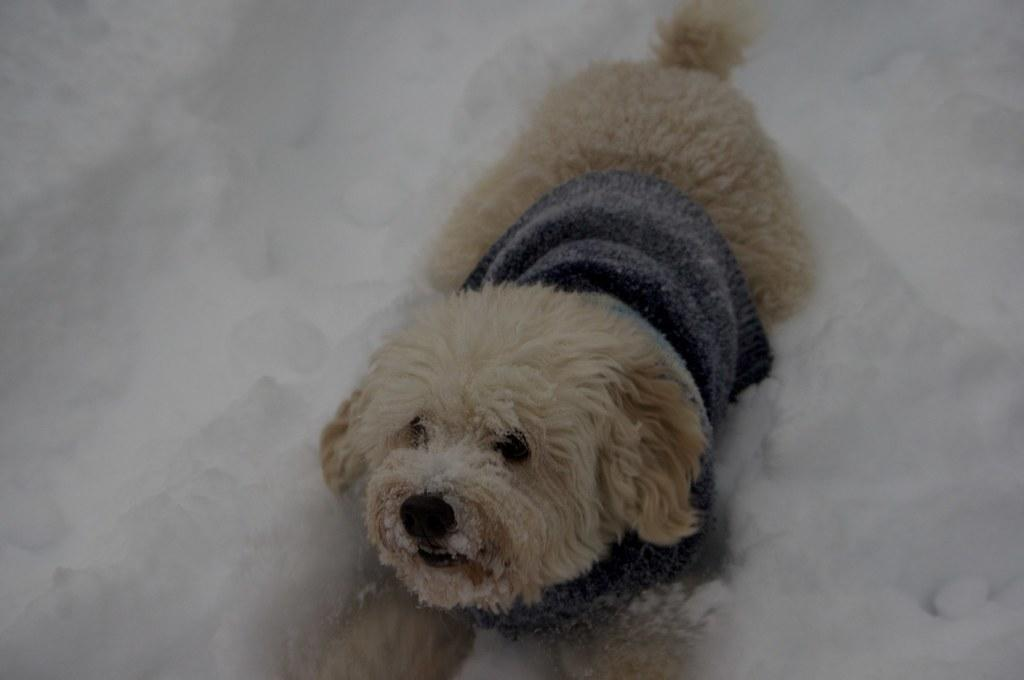What is the main subject in the foreground of the image? There is a dog in the foreground of the image. What type of terrain is the dog on? The dog is on the snow. What type of locket is the dog wearing around its neck in the image? There is no locket visible around the dog's neck in the image. How does the dog's bone expand in the image? There is no bone present in the image, so it cannot be determined how it might expand. 